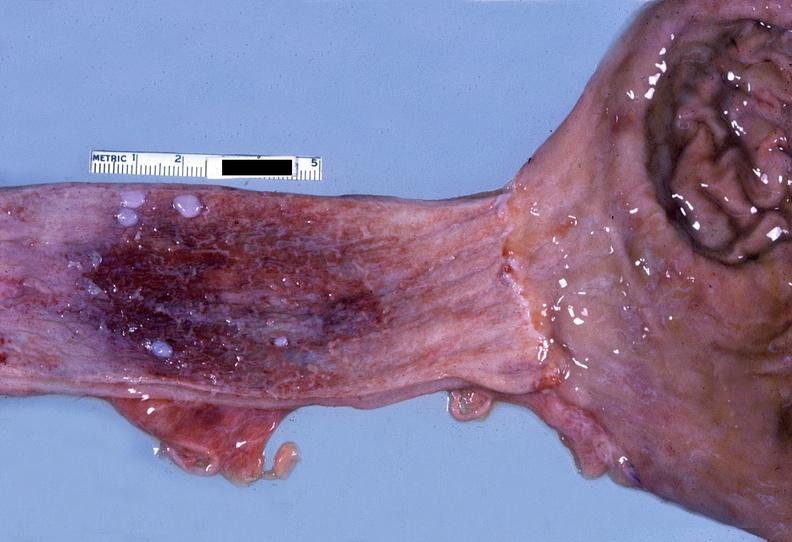does this image show esophagus, herpes esophagitis?
Answer the question using a single word or phrase. Yes 